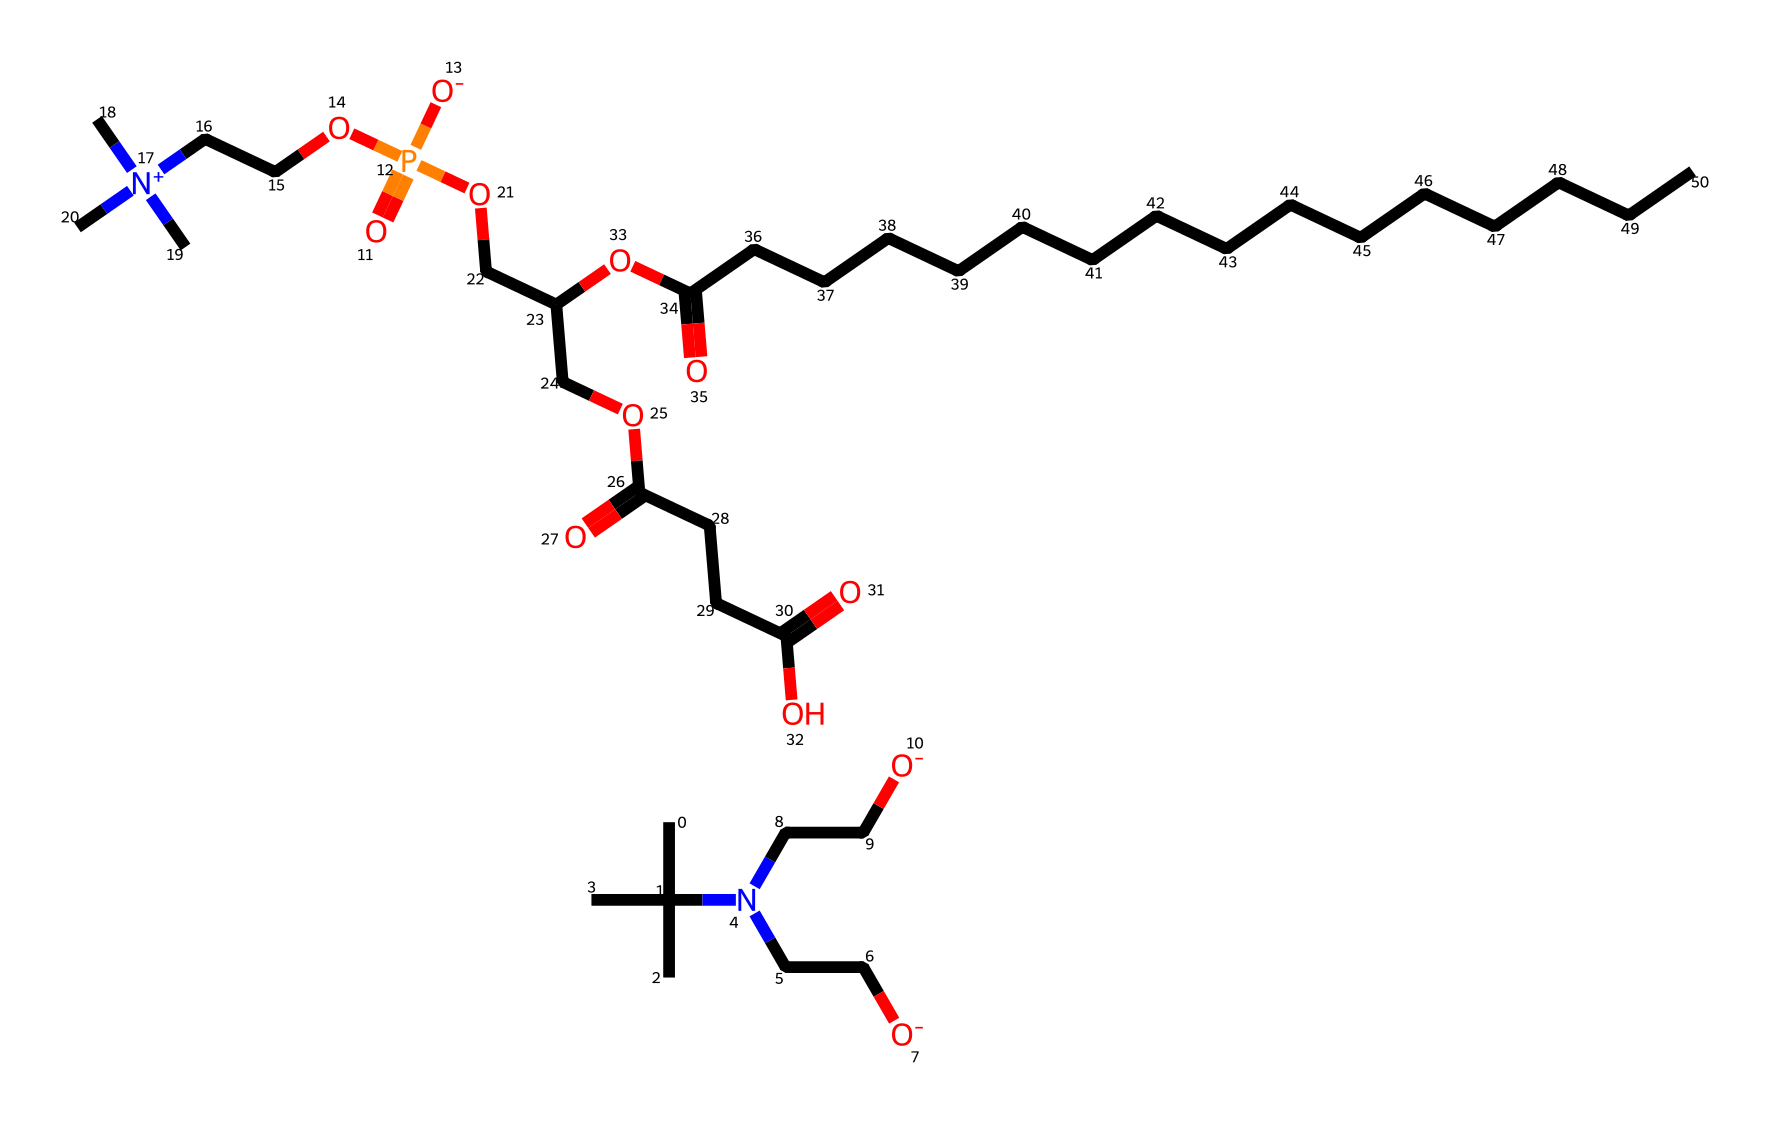What is the molecular weight of lecithin based on this chemical representation? To determine the molecular weight, you need to identify the number of each type of atom in the chemical formula derived from the SMILES representation. By counting the carbon, hydrogen, oxygen, and nitrogen atoms, and multiplying by their respective atomic weights (C=12, H=1, O=16, N=14), you can sum these to get the total molecular weight.
Answer: approximately 780 g/mol How many nitrogen atoms are present in this lecithin molecule? Counting the nitrogen atoms in the SMILES representation directly reveals their presence. In this case, there are two nitrogen atoms in the structure.
Answer: 2 What type of chemical compound is lecithin classified as? Lecithin is considered a phospholipid, a specific subclass of lipids, due to its structure containing glycerol, fatty acids, phosphate, and nitrogen.
Answer: phospholipid What is the functional group associated with the phosphate in lecithin? The phosphate group is typically represented as -OPO3 in chemical structures. In the SMILES notation given, the presence of phosphorus surrounded by four oxygen atoms indicates the phosphate functional group.
Answer: phosphate How many carbon atoms are in the lecithin molecule? To find the total number of carbon atoms from the SMILES, count each "C" in the given structure, including those in branches and side chains. The total counts up to 39 carbon atoms.
Answer: 39 